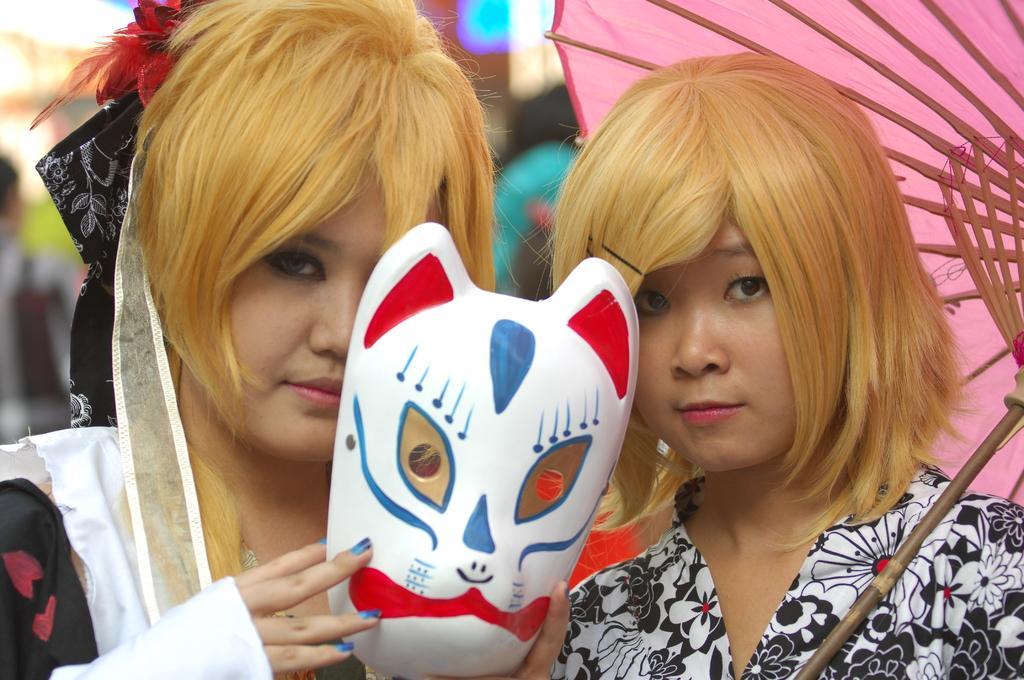How would you summarize this image in a sentence or two? In this image we can see a woman holding the mask. We can also see another woman holding an umbrella. The background is blurred with a person on the left. 